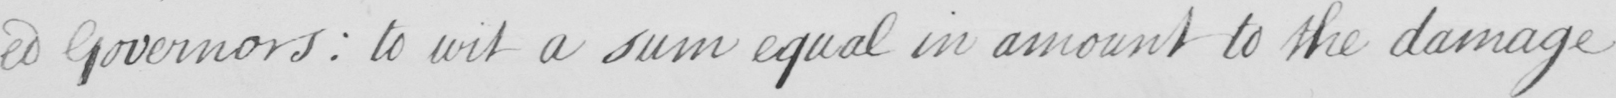Can you tell me what this handwritten text says? -ed Governors :  to wit a sum equal in amount to the damage 